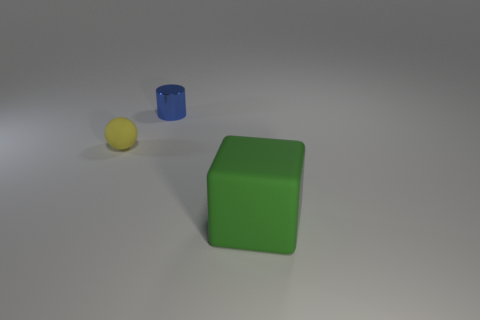Add 1 small rubber things. How many objects exist? 4 Subtract all cylinders. How many objects are left? 2 Subtract all rubber objects. Subtract all big green matte blocks. How many objects are left? 0 Add 1 tiny rubber balls. How many tiny rubber balls are left? 2 Add 1 tiny metal objects. How many tiny metal objects exist? 2 Subtract 0 cyan blocks. How many objects are left? 3 